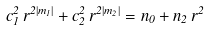Convert formula to latex. <formula><loc_0><loc_0><loc_500><loc_500>c _ { 1 } ^ { 2 } \, r ^ { 2 | m _ { 1 } | } + c _ { 2 } ^ { 2 } \, r ^ { 2 | m _ { 2 } | } = n _ { 0 } + n _ { 2 } \, r ^ { 2 }</formula> 